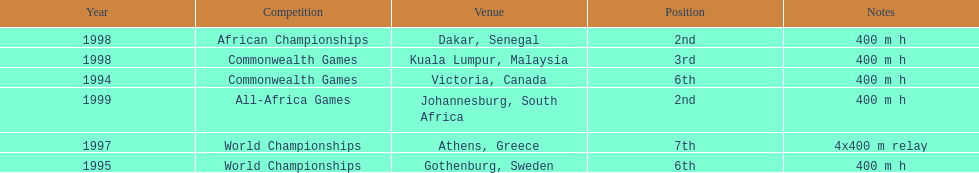In what years did ken harnden do better that 5th place? 1998, 1999. 